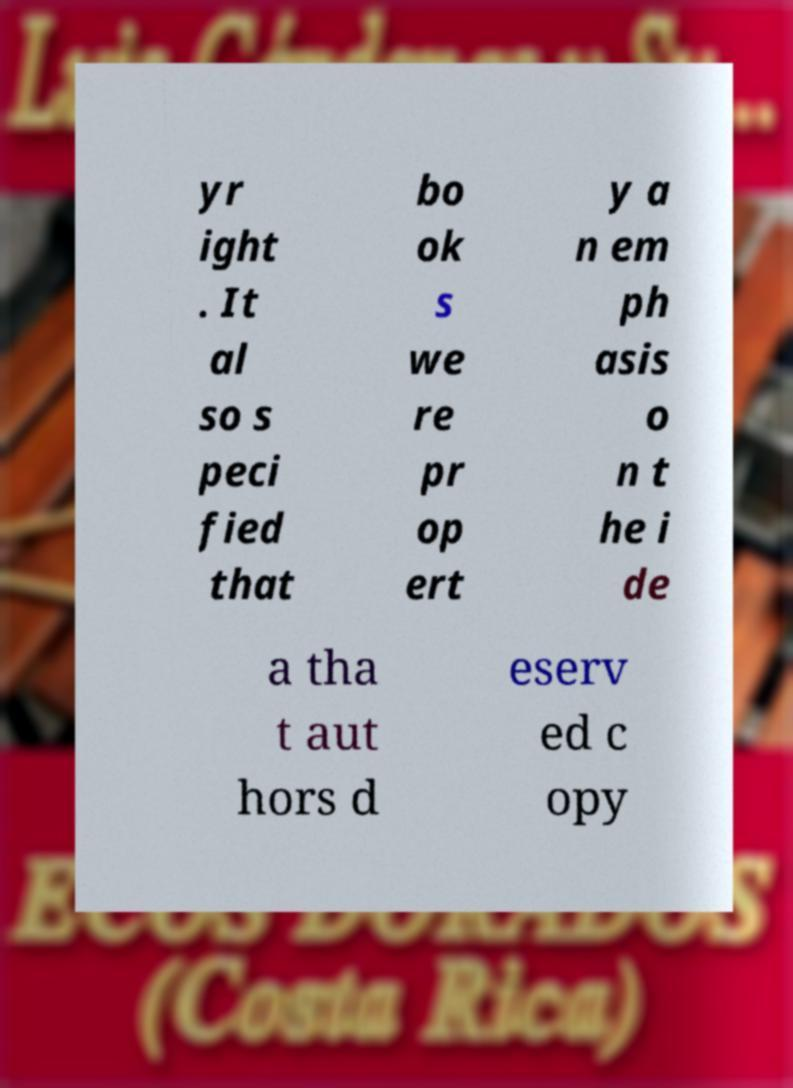Could you extract and type out the text from this image? yr ight . It al so s peci fied that bo ok s we re pr op ert y a n em ph asis o n t he i de a tha t aut hors d eserv ed c opy 